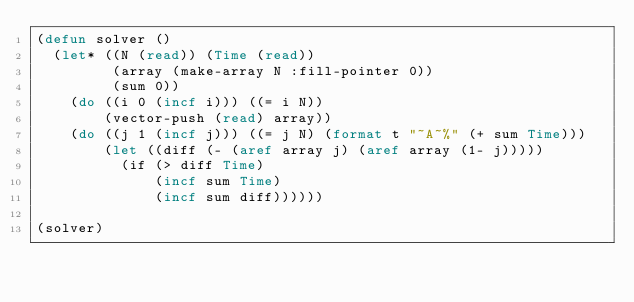Convert code to text. <code><loc_0><loc_0><loc_500><loc_500><_Lisp_>(defun solver ()
  (let* ((N (read)) (Time (read))
         (array (make-array N :fill-pointer 0))
         (sum 0))
    (do ((i 0 (incf i))) ((= i N))
        (vector-push (read) array))
    (do ((j 1 (incf j))) ((= j N) (format t "~A~%" (+ sum Time)))
        (let ((diff (- (aref array j) (aref array (1- j)))))
          (if (> diff Time)
              (incf sum Time)
              (incf sum diff))))))

(solver)</code> 